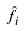<formula> <loc_0><loc_0><loc_500><loc_500>\hat { f } _ { i }</formula> 